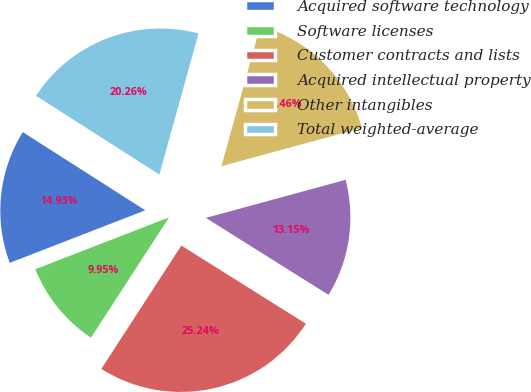Convert chart. <chart><loc_0><loc_0><loc_500><loc_500><pie_chart><fcel>Acquired software technology<fcel>Software licenses<fcel>Customer contracts and lists<fcel>Acquired intellectual property<fcel>Other intangibles<fcel>Total weighted-average<nl><fcel>14.93%<fcel>9.95%<fcel>25.24%<fcel>13.15%<fcel>16.46%<fcel>20.26%<nl></chart> 